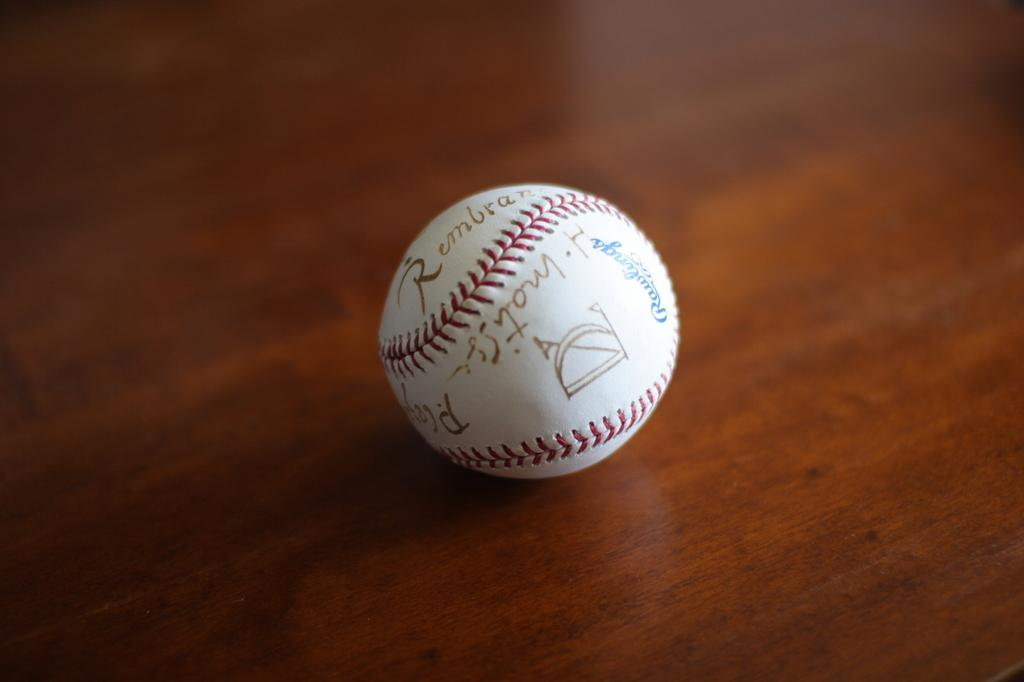What object is present in the image? There is a ball in the image. Where is the ball located? The ball is placed on a table. What type of locket is hanging from the ball in the image? There is no locket present in the image; it only features a ball placed on a table. What kind of music can be heard coming from the ball in the image? There is no music or sound associated with the ball in the image. 